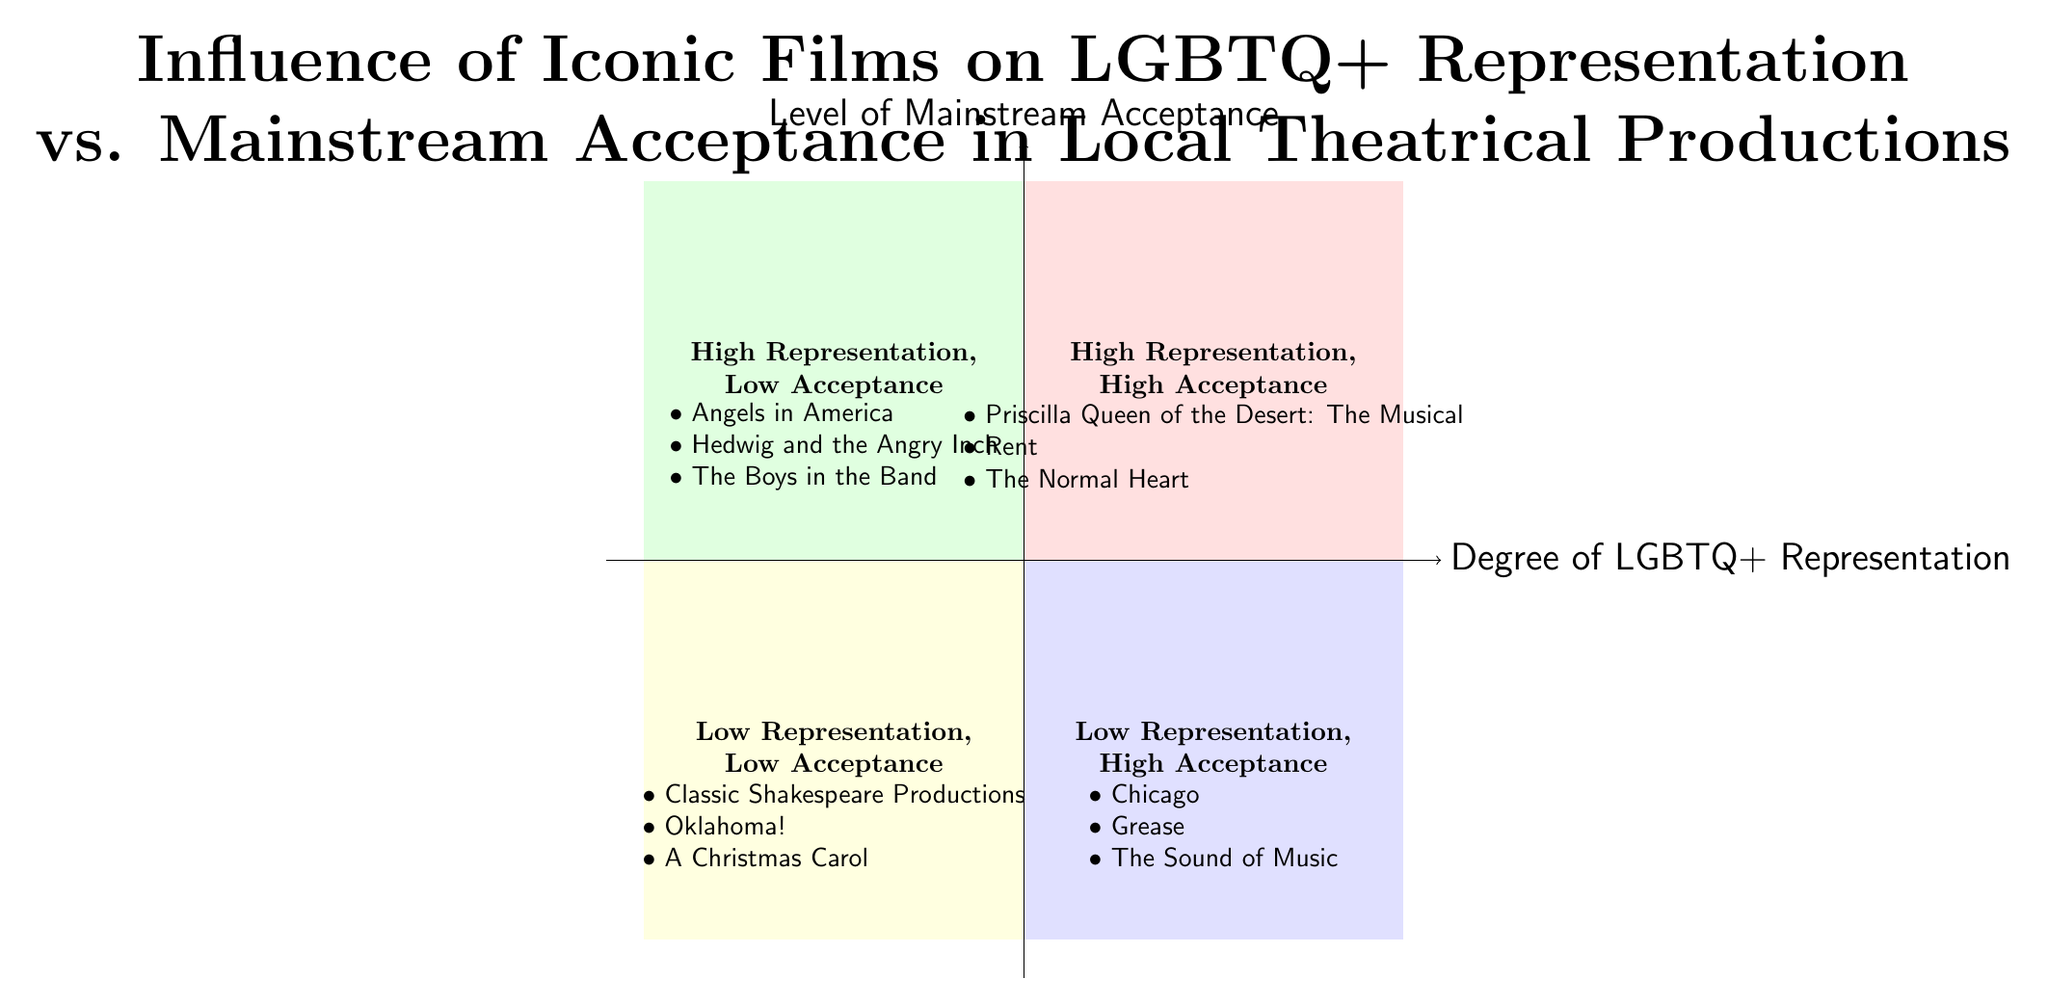What is the title of the work in the quadrant labeled "High Representation, High Acceptance"? The quadrant labeled "High Representation, High Acceptance" contains the titles of works listed within it, one of which is "Priscilla Queen of the Desert: The Musical."
Answer: Priscilla Queen of the Desert: The Musical How many works are in the "Low Representation, High Acceptance" quadrant? The "Low Representation, High Acceptance" quadrant contains three works listed, specifically "Chicago," "Grease," and "The Sound of Music," thus the total count is three.
Answer: 3 Name one work from the "High Representation, Low Acceptance" quadrant. In the "High Representation, Low Acceptance" quadrant, one of the works listed is "Angels in America."
Answer: Angels in America In which quadrant would you find "A Christmas Carol"? "A Christmas Carol" is listed in the "Low Representation, Low Acceptance" quadrant, indicating that it does not depict much LGBTQ+ representation and has low mainstream acceptance in this analysis.
Answer: Low Representation, Low Acceptance Which quadrant contains works that are both highly representative of LGBTQ+ themes and widely accepted? The quadrant that signifies both high representation of LGBTQ+ themes and high mainstream acceptance is the "High Representation, High Acceptance" quadrant, which includes notable works such as "Priscilla Queen of the Desert: The Musical."
Answer: High Representation, High Acceptance What is the significance of "The Normal Heart" in the context of this diagram? "The Normal Heart" is found in the "High Representation, High Acceptance" quadrant, indicating its significant role in promoting LGBTQ+ visibility and achieving acceptance in theatrical productions.
Answer: High Representation, High Acceptance Which quadrant would indicate a lack of LGBTQ+ representation along with low acceptance? The quadrant that reflects both a lack of LGBTQ+ representation and low acceptance is the "Low Representation, Low Acceptance" quadrant, which includes works like "Classic Shakespeare Productions," "Oklahoma!" and "A Christmas Carol."
Answer: Low Representation, Low Acceptance How does "Rent" compare to "Hedwig and the Angry Inch" regarding mainstream acceptance? "Rent," which is listed in the "High Representation, High Acceptance" quadrant, demonstrates a higher level of mainstream acceptance than "Hedwig and the Angry Inch," which is placed in the "High Representation, Low Acceptance" quadrant.
Answer: Higher mainstream acceptance What is the primary focus of the diagram? The diagram's primary focus is to illustrate the influence of iconic films on LGBTQ+ representation versus their level of mainstream acceptance in local theatrical productions through a visual quadrant analysis.
Answer: Influence of Iconic Films on LGBTQ+ Representation vs. Mainstream Acceptance 